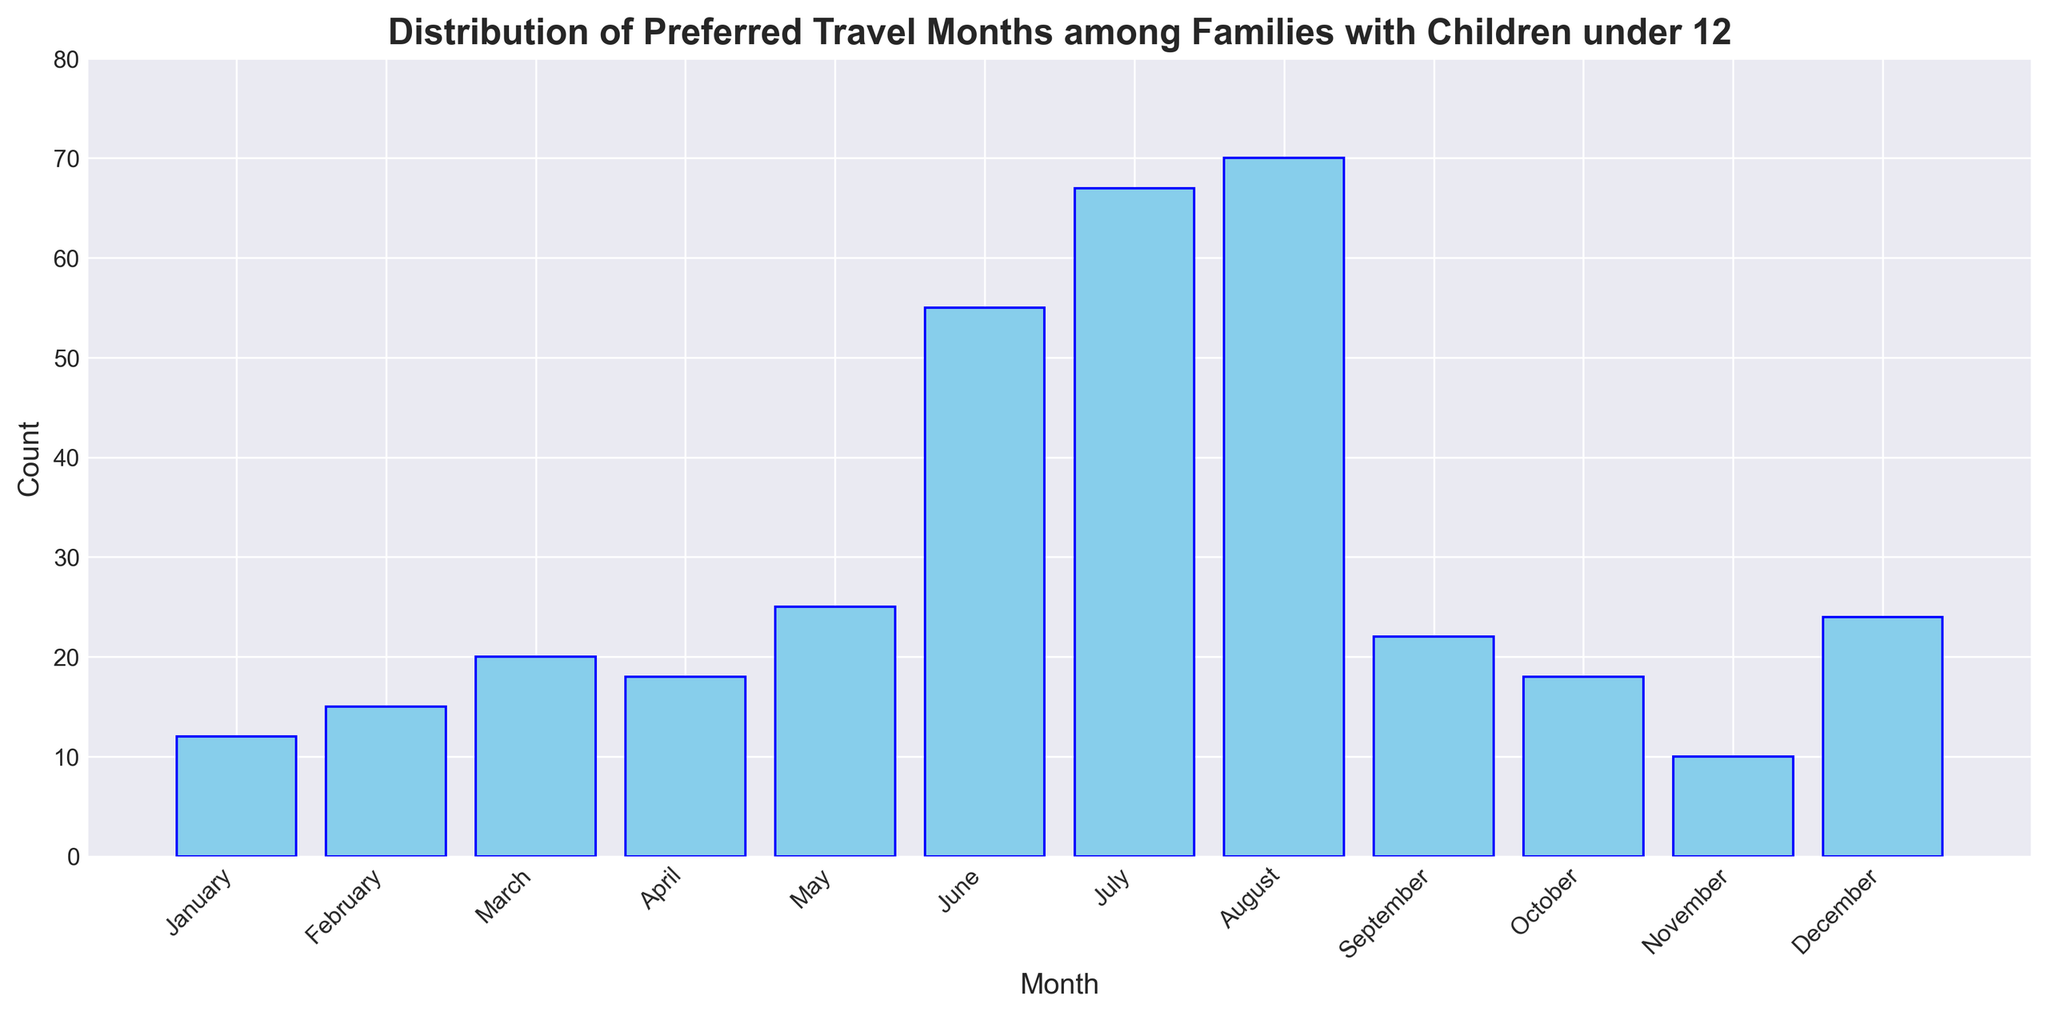Which month has the highest number of preferred travel counts among families with children under 12? Observe the heights of the bars representing each month. The highest bar corresponds to August.
Answer: August Which month has the lowest number of preferred travel counts among families with children under 12? Observe the heights of the bars representing each month. The shortest bar corresponds to November.
Answer: November How many months have a travel count greater than 50? Review the heights of all the bars and identify those that exceed 50 in count. There are three such months: June, July, and August.
Answer: 3 What is the combined travel count for June and July? Extract the counts for June (55) and July (67) and add them together: 55 + 67 = 122.
Answer: 122 Is the preferred travel count in May greater than the travel count in March? Compare the heights of the bars for May and March. May has a bar height (25) that is greater than March (20).
Answer: Yes Which month shows a count just above 20 but below 25? Identify the bar heights between 20 and 25. The month with a count of 22 is September.
Answer: September What is the average travel count from January to April? Extract the counts for January (12), February (15), March (20), and April (18) and calculate the average: (12 + 15 + 20 + 18) / 4 = 16.25.
Answer: 16.25 Are the counts for December and February equal? Compare the bar heights for December (24) and February (15). They are not equal.
Answer: No How much higher is the travel count in August compared to December? Subtract the December count (24) from the August count (70): 70 - 24 = 46.
Answer: 46 What is the median value of preferred travel months for the entire year? First, list all counts in ascending order: 10, 12, 15, 18, 18, 20, 22, 24, 25, 55, 67, 70. The middle values (for an even number of data points) are the 6th (20) and 7th (22). The median is (20 + 22) / 2 = 21.
Answer: 21 